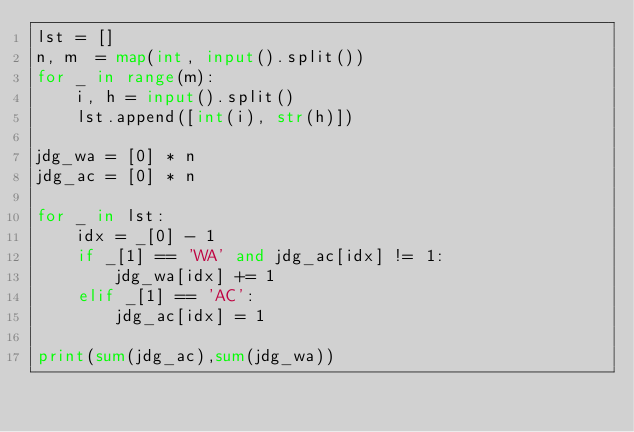Convert code to text. <code><loc_0><loc_0><loc_500><loc_500><_Python_>lst = []
n, m  = map(int, input().split())
for _ in range(m):
    i, h = input().split()
    lst.append([int(i), str(h)])

jdg_wa = [0] * n 
jdg_ac = [0] * n

for _ in lst:
    idx = _[0] - 1
    if _[1] == 'WA' and jdg_ac[idx] != 1:
        jdg_wa[idx] += 1
    elif _[1] == 'AC':
        jdg_ac[idx] = 1
        
print(sum(jdg_ac),sum(jdg_wa))</code> 